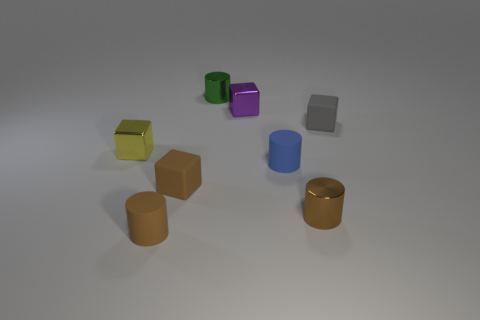Subtract all brown matte blocks. How many blocks are left? 3 Add 2 brown rubber spheres. How many objects exist? 10 Subtract all brown spheres. How many brown cylinders are left? 2 Subtract all gray cubes. How many cubes are left? 3 Add 2 small rubber cubes. How many small rubber cubes exist? 4 Subtract 1 gray blocks. How many objects are left? 7 Subtract 3 cylinders. How many cylinders are left? 1 Subtract all green cubes. Subtract all green balls. How many cubes are left? 4 Subtract all small brown rubber things. Subtract all small metallic things. How many objects are left? 2 Add 1 small green shiny cylinders. How many small green shiny cylinders are left? 2 